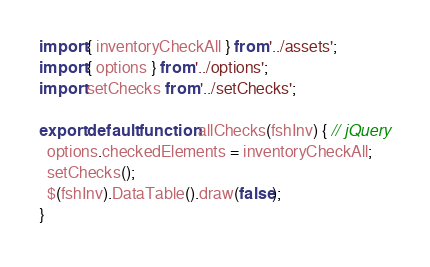Convert code to text. <code><loc_0><loc_0><loc_500><loc_500><_JavaScript_>import { inventoryCheckAll } from '../assets';
import { options } from '../options';
import setChecks from '../setChecks';

export default function allChecks(fshInv) { // jQuery
  options.checkedElements = inventoryCheckAll;
  setChecks();
  $(fshInv).DataTable().draw(false);
}
</code> 